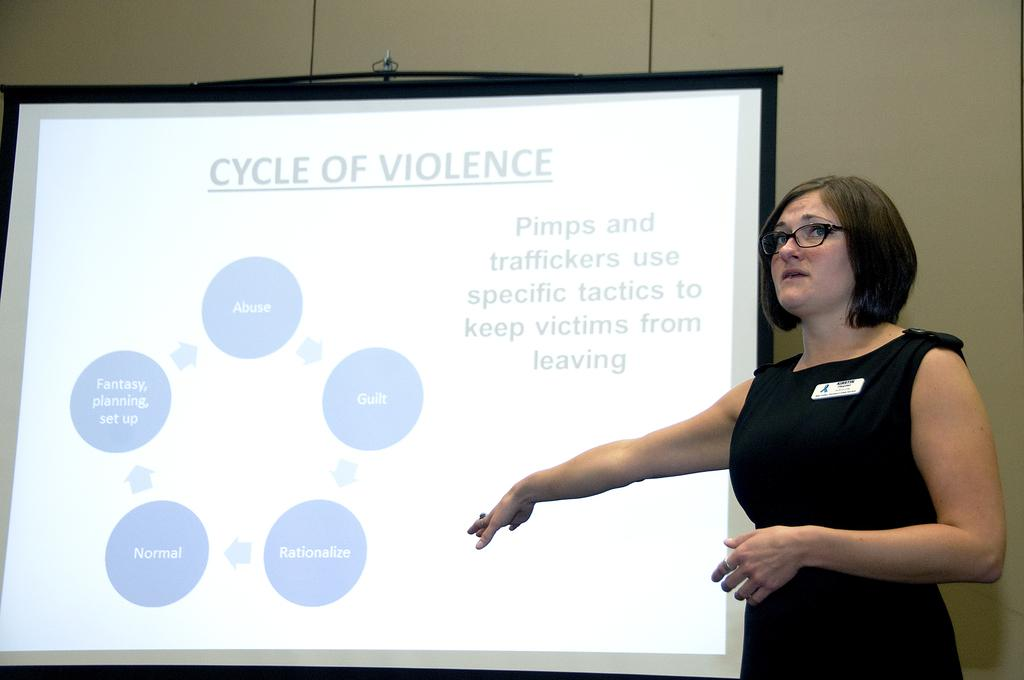What is located on the right side of the image? There is a woman on the right side of the image. What is the woman wearing in the image? The woman is wearing spectacles in the image. What can be seen behind the woman in the image? There is a projector screen behind the woman in the image. How many cows are visible in the image? There are no cows present in the image. What type of bag is the woman carrying in the image? The image does not show the woman carrying a bag. 